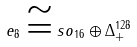Convert formula to latex. <formula><loc_0><loc_0><loc_500><loc_500>e _ { 8 } \cong s o _ { 1 6 } \oplus \Delta _ { + } ^ { 1 2 8 }</formula> 